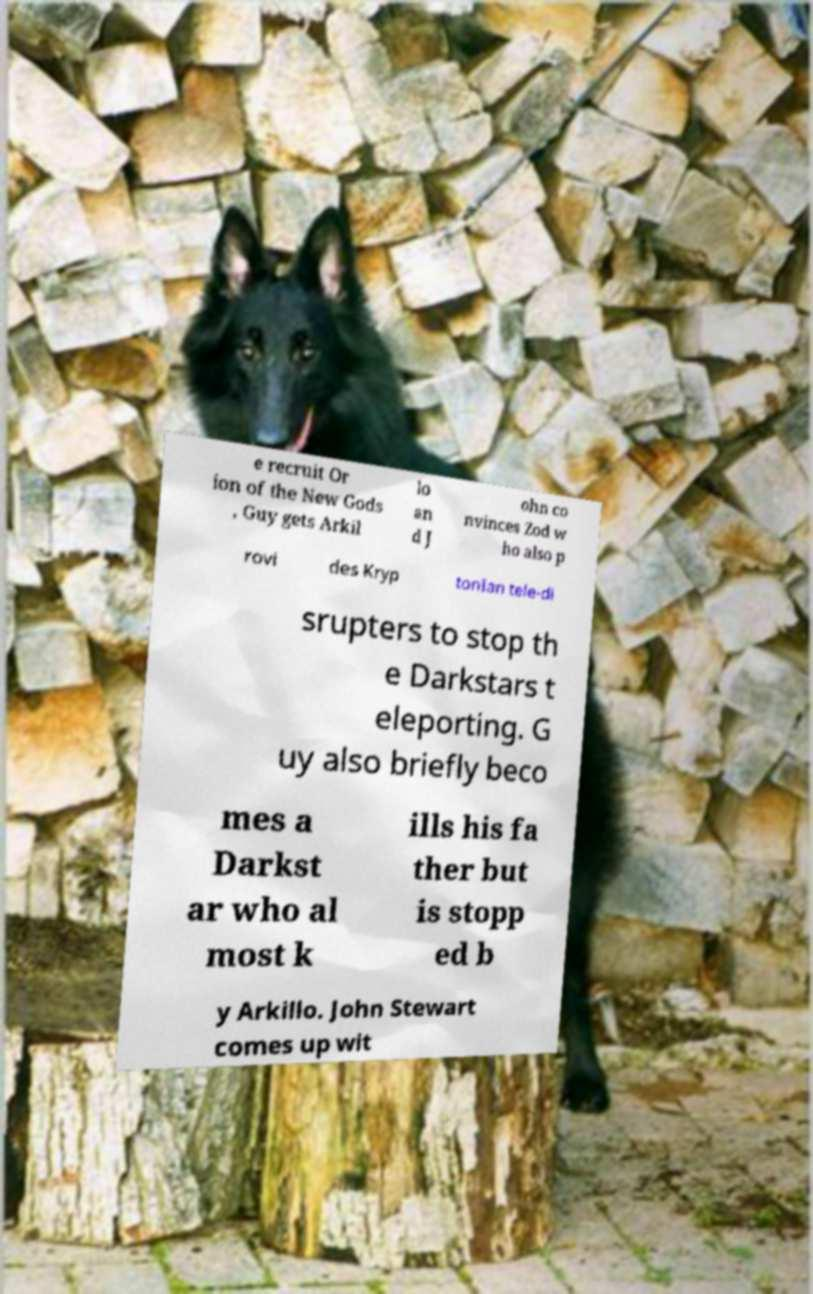Please read and relay the text visible in this image. What does it say? e recruit Or ion of the New Gods , Guy gets Arkil lo an d J ohn co nvinces Zod w ho also p rovi des Kryp tonIan tele-di srupters to stop th e Darkstars t eleporting. G uy also briefly beco mes a Darkst ar who al most k ills his fa ther but is stopp ed b y Arkillo. John Stewart comes up wit 